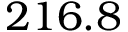<formula> <loc_0><loc_0><loc_500><loc_500>2 1 6 . 8</formula> 